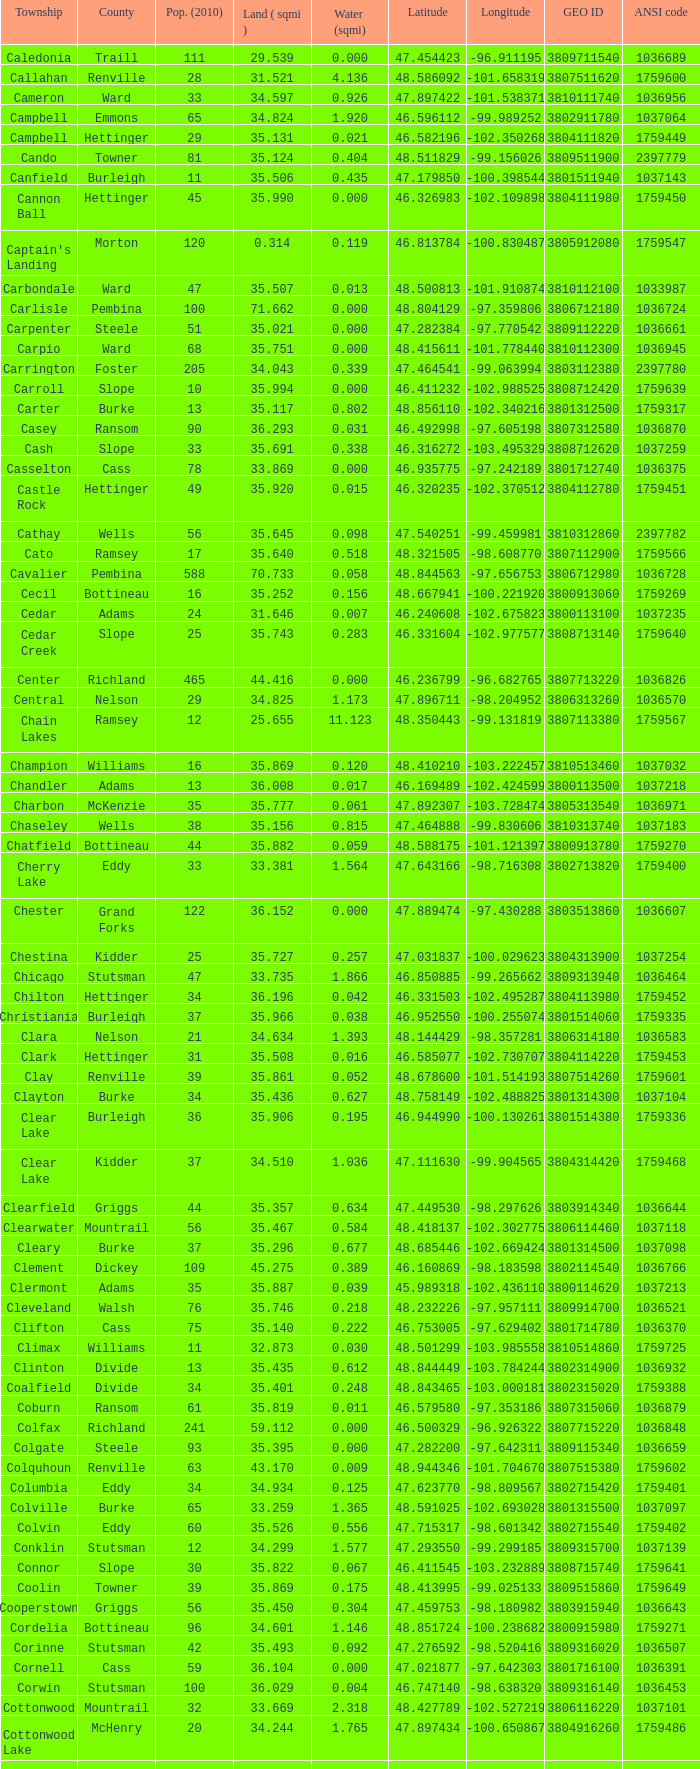302775? Mountrail. 